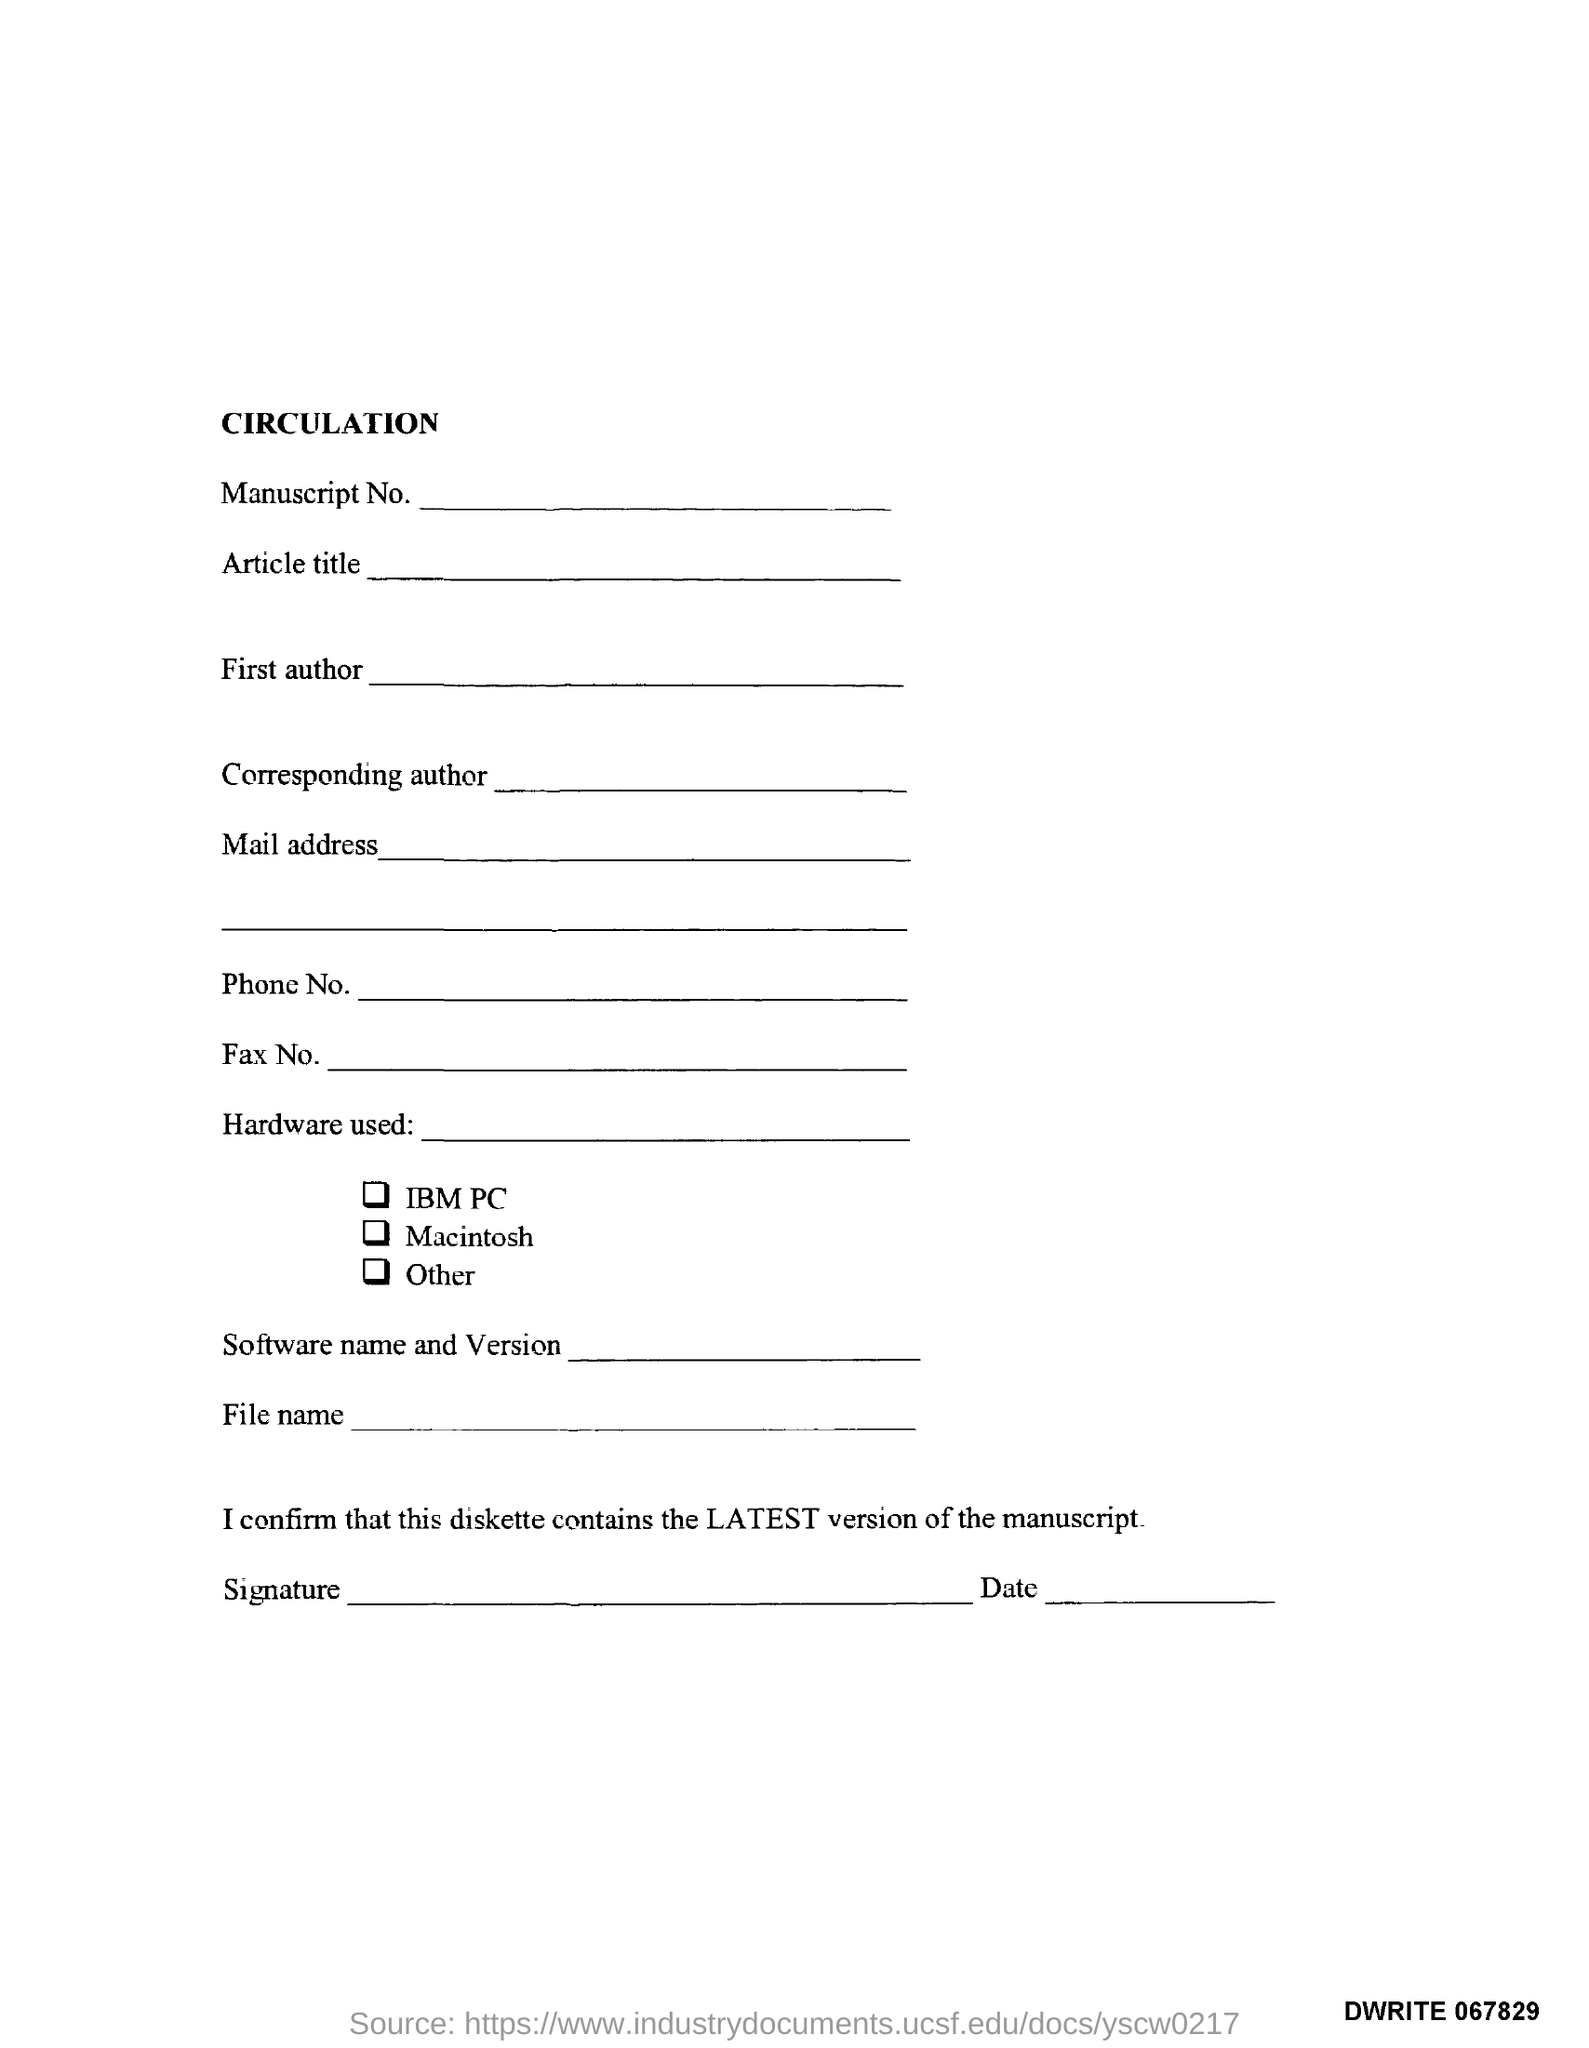Identify some key points in this picture. The title of the document is 'circulation.' The document number is DWRITE 067829. 